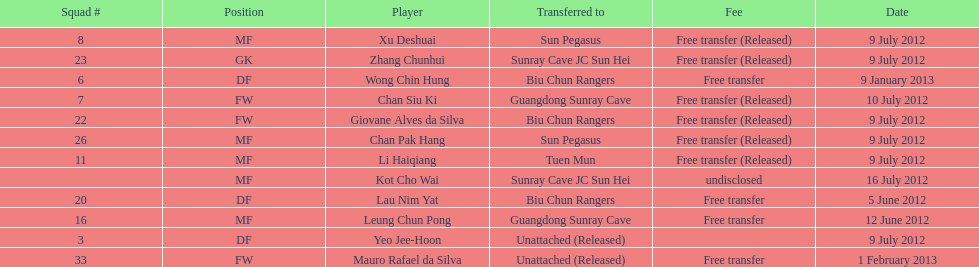Which team did lau nim yat play for after he was transferred? Biu Chun Rangers. 